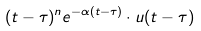Convert formula to latex. <formula><loc_0><loc_0><loc_500><loc_500>( t - \tau ) ^ { n } e ^ { - \alpha ( t - \tau ) } \cdot u ( t - \tau )</formula> 